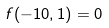<formula> <loc_0><loc_0><loc_500><loc_500>f ( - 1 0 , 1 ) = 0</formula> 